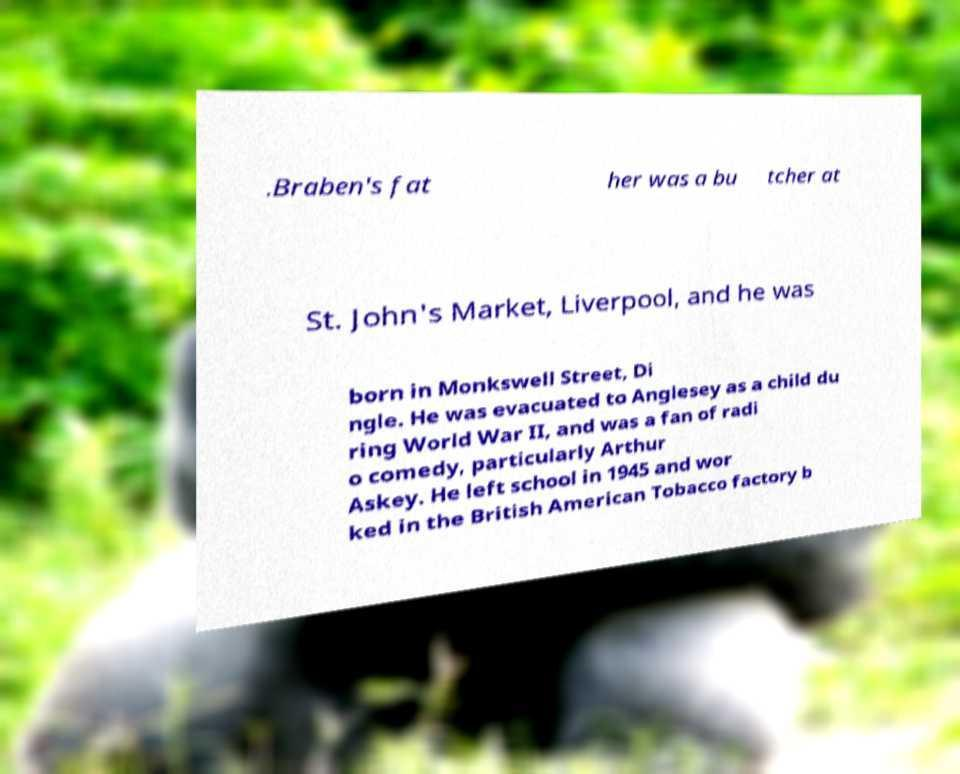Could you assist in decoding the text presented in this image and type it out clearly? .Braben's fat her was a bu tcher at St. John's Market, Liverpool, and he was born in Monkswell Street, Di ngle. He was evacuated to Anglesey as a child du ring World War II, and was a fan of radi o comedy, particularly Arthur Askey. He left school in 1945 and wor ked in the British American Tobacco factory b 